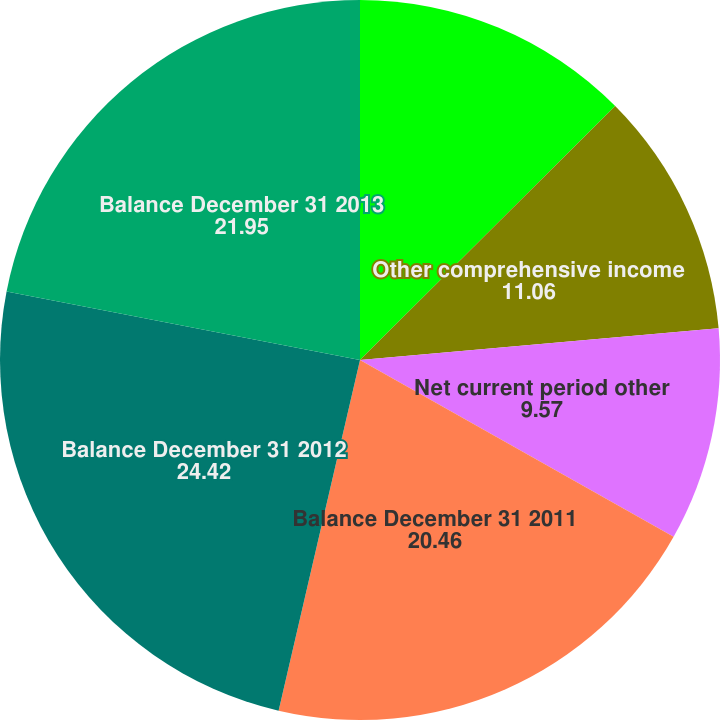Convert chart to OTSL. <chart><loc_0><loc_0><loc_500><loc_500><pie_chart><fcel>Balance December 31 2010<fcel>Other comprehensive income<fcel>Net current period other<fcel>Balance December 31 2011<fcel>Balance December 31 2012<fcel>Balance December 31 2013<nl><fcel>12.54%<fcel>11.06%<fcel>9.57%<fcel>20.46%<fcel>24.42%<fcel>21.95%<nl></chart> 